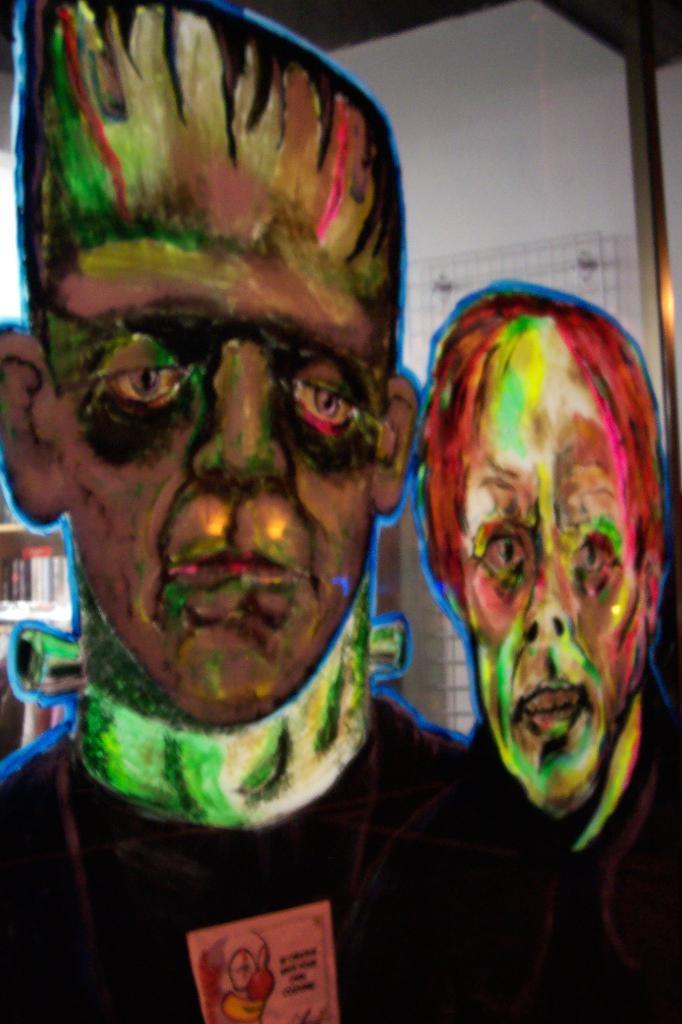Can you describe this image briefly? In this image there are paintings on the wall. In the background there is bookshelf. 